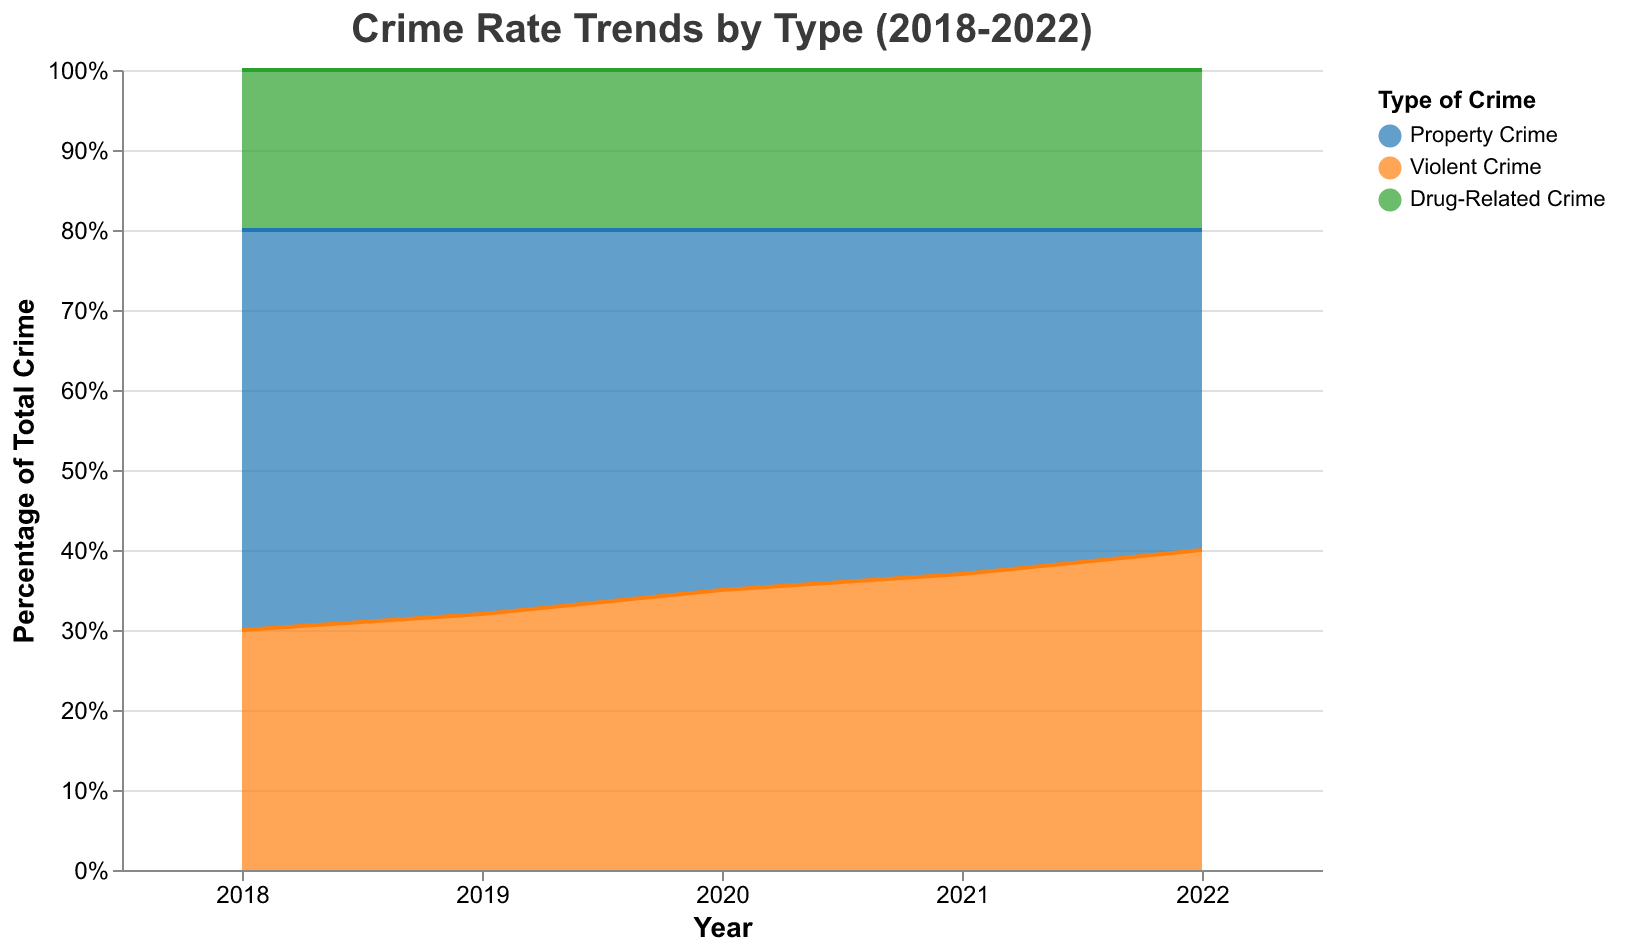What is the title of the chart? The title of the chart is displayed at the top and reads "Crime Rate Trends by Type (2018-2022)."
Answer: Crime Rate Trends by Type (2018-2022) How many years are shown in the chart? The x-axis of the chart lists the years, which include 2018, 2019, 2020, 2021, and 2022.
Answer: 5 Which type of crime had the highest percentage in 2018? By looking at the chart for the year 2018, Property Crime occupies the largest part of the stacked area, with a percentage of 50%.
Answer: Property Crime What is the percentage of Drug-Related Crime in all years? The section for Drug-Related Crime is constant across all years in the chart, with the percentage always being 20%.
Answer: 20% Compare the trend of Violent Crime from 2018 to 2022. Did it increase or decrease? Observing the area related to Violent Crime, the percentage increased from 30% in 2018 to 40% in 2022.
Answer: Increase Did Property Crime decrease or increase between 2018 and 2022? The chart shows the section for Property Crime shrinking from 50% in 2018 to 40% in 2022.
Answer: Decrease In which year did Violent Crime have the same percentage as Property Crime? By examining the proportions for each year, 2022 is the year when Property Crime and Violent Crime both have a percentage of 40%.
Answer: 2022 What is the combined percentage of Property Crime and Violent Crime in 2020? Adding the percentages for Property Crime (45%) and Violent Crime (35%) in 2020 results in a combined percentage of 80%.
Answer: 80% Which type of crime shows no change in its percentage from 2018 to 2022? The chart indicates that the section for Drug-Related Crime remains constant at 20% throughout the entire period.
Answer: Drug-Related Crime By how much did the percentage of Property Crime decrease from 2019 to 2020? Subtracting the percentage of Property Crime in 2020 (45%) from the percentage in 2019 (48%) results in a decrease of 3%.
Answer: 3% 